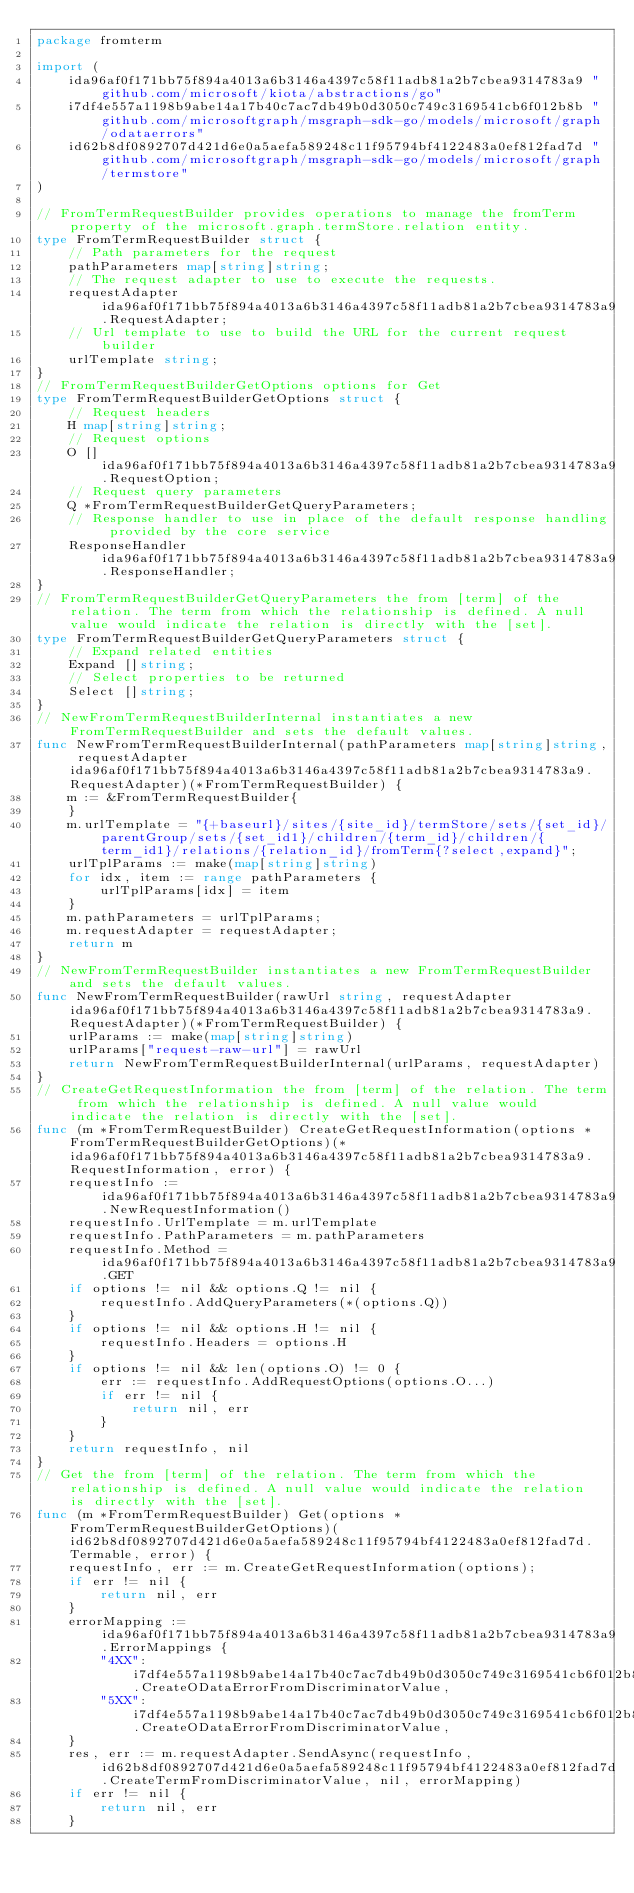Convert code to text. <code><loc_0><loc_0><loc_500><loc_500><_Go_>package fromterm

import (
    ida96af0f171bb75f894a4013a6b3146a4397c58f11adb81a2b7cbea9314783a9 "github.com/microsoft/kiota/abstractions/go"
    i7df4e557a1198b9abe14a17b40c7ac7db49b0d3050c749c3169541cb6f012b8b "github.com/microsoftgraph/msgraph-sdk-go/models/microsoft/graph/odataerrors"
    id62b8df0892707d421d6e0a5aefa589248c11f95794bf4122483a0ef812fad7d "github.com/microsoftgraph/msgraph-sdk-go/models/microsoft/graph/termstore"
)

// FromTermRequestBuilder provides operations to manage the fromTerm property of the microsoft.graph.termStore.relation entity.
type FromTermRequestBuilder struct {
    // Path parameters for the request
    pathParameters map[string]string;
    // The request adapter to use to execute the requests.
    requestAdapter ida96af0f171bb75f894a4013a6b3146a4397c58f11adb81a2b7cbea9314783a9.RequestAdapter;
    // Url template to use to build the URL for the current request builder
    urlTemplate string;
}
// FromTermRequestBuilderGetOptions options for Get
type FromTermRequestBuilderGetOptions struct {
    // Request headers
    H map[string]string;
    // Request options
    O []ida96af0f171bb75f894a4013a6b3146a4397c58f11adb81a2b7cbea9314783a9.RequestOption;
    // Request query parameters
    Q *FromTermRequestBuilderGetQueryParameters;
    // Response handler to use in place of the default response handling provided by the core service
    ResponseHandler ida96af0f171bb75f894a4013a6b3146a4397c58f11adb81a2b7cbea9314783a9.ResponseHandler;
}
// FromTermRequestBuilderGetQueryParameters the from [term] of the relation. The term from which the relationship is defined. A null value would indicate the relation is directly with the [set].
type FromTermRequestBuilderGetQueryParameters struct {
    // Expand related entities
    Expand []string;
    // Select properties to be returned
    Select []string;
}
// NewFromTermRequestBuilderInternal instantiates a new FromTermRequestBuilder and sets the default values.
func NewFromTermRequestBuilderInternal(pathParameters map[string]string, requestAdapter ida96af0f171bb75f894a4013a6b3146a4397c58f11adb81a2b7cbea9314783a9.RequestAdapter)(*FromTermRequestBuilder) {
    m := &FromTermRequestBuilder{
    }
    m.urlTemplate = "{+baseurl}/sites/{site_id}/termStore/sets/{set_id}/parentGroup/sets/{set_id1}/children/{term_id}/children/{term_id1}/relations/{relation_id}/fromTerm{?select,expand}";
    urlTplParams := make(map[string]string)
    for idx, item := range pathParameters {
        urlTplParams[idx] = item
    }
    m.pathParameters = urlTplParams;
    m.requestAdapter = requestAdapter;
    return m
}
// NewFromTermRequestBuilder instantiates a new FromTermRequestBuilder and sets the default values.
func NewFromTermRequestBuilder(rawUrl string, requestAdapter ida96af0f171bb75f894a4013a6b3146a4397c58f11adb81a2b7cbea9314783a9.RequestAdapter)(*FromTermRequestBuilder) {
    urlParams := make(map[string]string)
    urlParams["request-raw-url"] = rawUrl
    return NewFromTermRequestBuilderInternal(urlParams, requestAdapter)
}
// CreateGetRequestInformation the from [term] of the relation. The term from which the relationship is defined. A null value would indicate the relation is directly with the [set].
func (m *FromTermRequestBuilder) CreateGetRequestInformation(options *FromTermRequestBuilderGetOptions)(*ida96af0f171bb75f894a4013a6b3146a4397c58f11adb81a2b7cbea9314783a9.RequestInformation, error) {
    requestInfo := ida96af0f171bb75f894a4013a6b3146a4397c58f11adb81a2b7cbea9314783a9.NewRequestInformation()
    requestInfo.UrlTemplate = m.urlTemplate
    requestInfo.PathParameters = m.pathParameters
    requestInfo.Method = ida96af0f171bb75f894a4013a6b3146a4397c58f11adb81a2b7cbea9314783a9.GET
    if options != nil && options.Q != nil {
        requestInfo.AddQueryParameters(*(options.Q))
    }
    if options != nil && options.H != nil {
        requestInfo.Headers = options.H
    }
    if options != nil && len(options.O) != 0 {
        err := requestInfo.AddRequestOptions(options.O...)
        if err != nil {
            return nil, err
        }
    }
    return requestInfo, nil
}
// Get the from [term] of the relation. The term from which the relationship is defined. A null value would indicate the relation is directly with the [set].
func (m *FromTermRequestBuilder) Get(options *FromTermRequestBuilderGetOptions)(id62b8df0892707d421d6e0a5aefa589248c11f95794bf4122483a0ef812fad7d.Termable, error) {
    requestInfo, err := m.CreateGetRequestInformation(options);
    if err != nil {
        return nil, err
    }
    errorMapping := ida96af0f171bb75f894a4013a6b3146a4397c58f11adb81a2b7cbea9314783a9.ErrorMappings {
        "4XX": i7df4e557a1198b9abe14a17b40c7ac7db49b0d3050c749c3169541cb6f012b8b.CreateODataErrorFromDiscriminatorValue,
        "5XX": i7df4e557a1198b9abe14a17b40c7ac7db49b0d3050c749c3169541cb6f012b8b.CreateODataErrorFromDiscriminatorValue,
    }
    res, err := m.requestAdapter.SendAsync(requestInfo, id62b8df0892707d421d6e0a5aefa589248c11f95794bf4122483a0ef812fad7d.CreateTermFromDiscriminatorValue, nil, errorMapping)
    if err != nil {
        return nil, err
    }</code> 